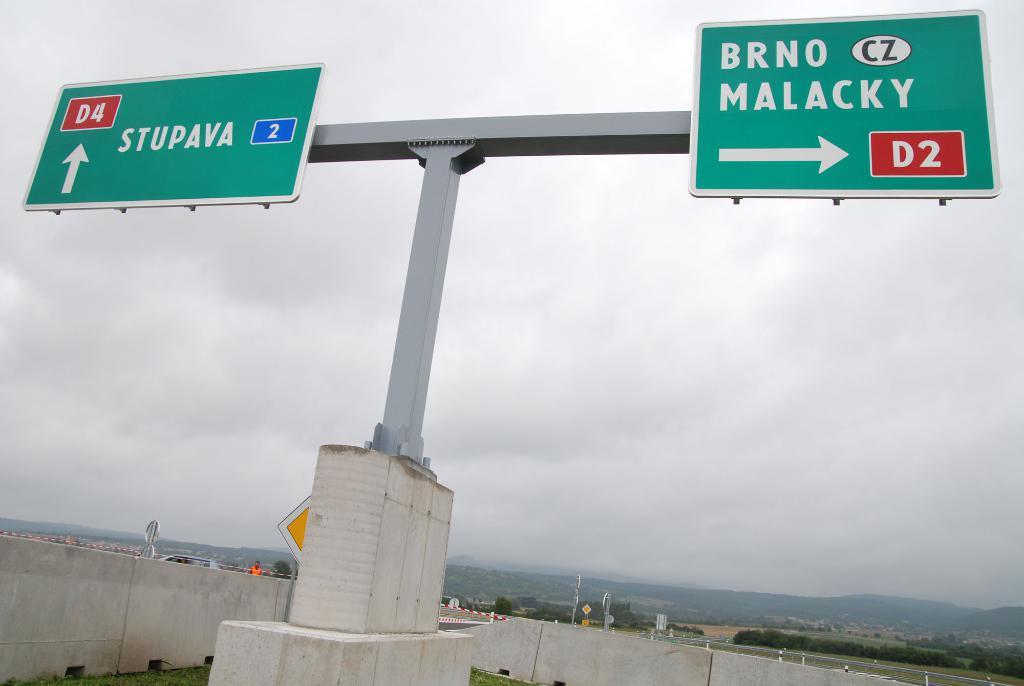Where will you go if you take a right?
Offer a very short reply. Brno malacky. 